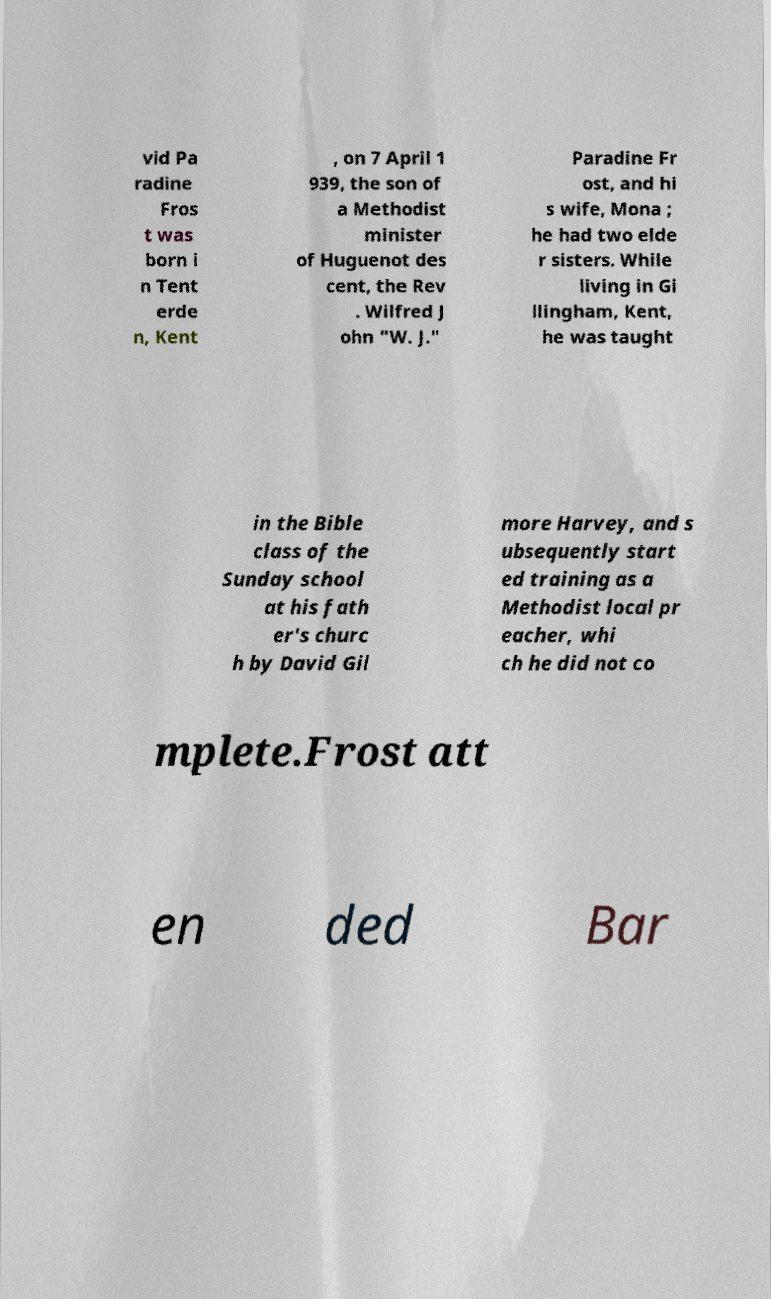Please identify and transcribe the text found in this image. vid Pa radine Fros t was born i n Tent erde n, Kent , on 7 April 1 939, the son of a Methodist minister of Huguenot des cent, the Rev . Wilfred J ohn "W. J." Paradine Fr ost, and hi s wife, Mona ; he had two elde r sisters. While living in Gi llingham, Kent, he was taught in the Bible class of the Sunday school at his fath er's churc h by David Gil more Harvey, and s ubsequently start ed training as a Methodist local pr eacher, whi ch he did not co mplete.Frost att en ded Bar 